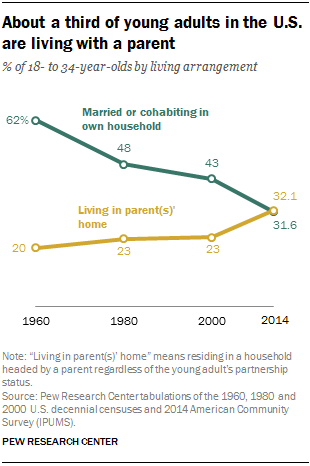Identify some key points in this picture. The difference in the living choices of young adults between 1960 and 2014 has decreased. The green and yellow lines came dangerously close to merging in the year 2014. 